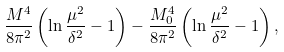Convert formula to latex. <formula><loc_0><loc_0><loc_500><loc_500>\frac { M ^ { 4 } } { 8 \pi ^ { 2 } } \left ( \ln \frac { \mu ^ { 2 } } { \delta ^ { 2 } } - 1 \right ) - \frac { M _ { 0 } ^ { 4 } } { 8 \pi ^ { 2 } } \left ( \ln \frac { \mu ^ { 2 } } { \delta ^ { 2 } } - 1 \right ) ,</formula> 